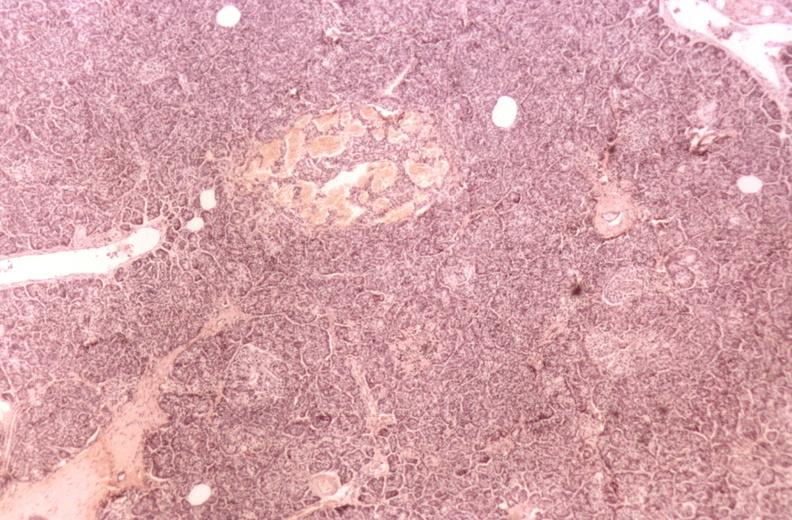where is this?
Answer the question using a single word or phrase. Pancreas 